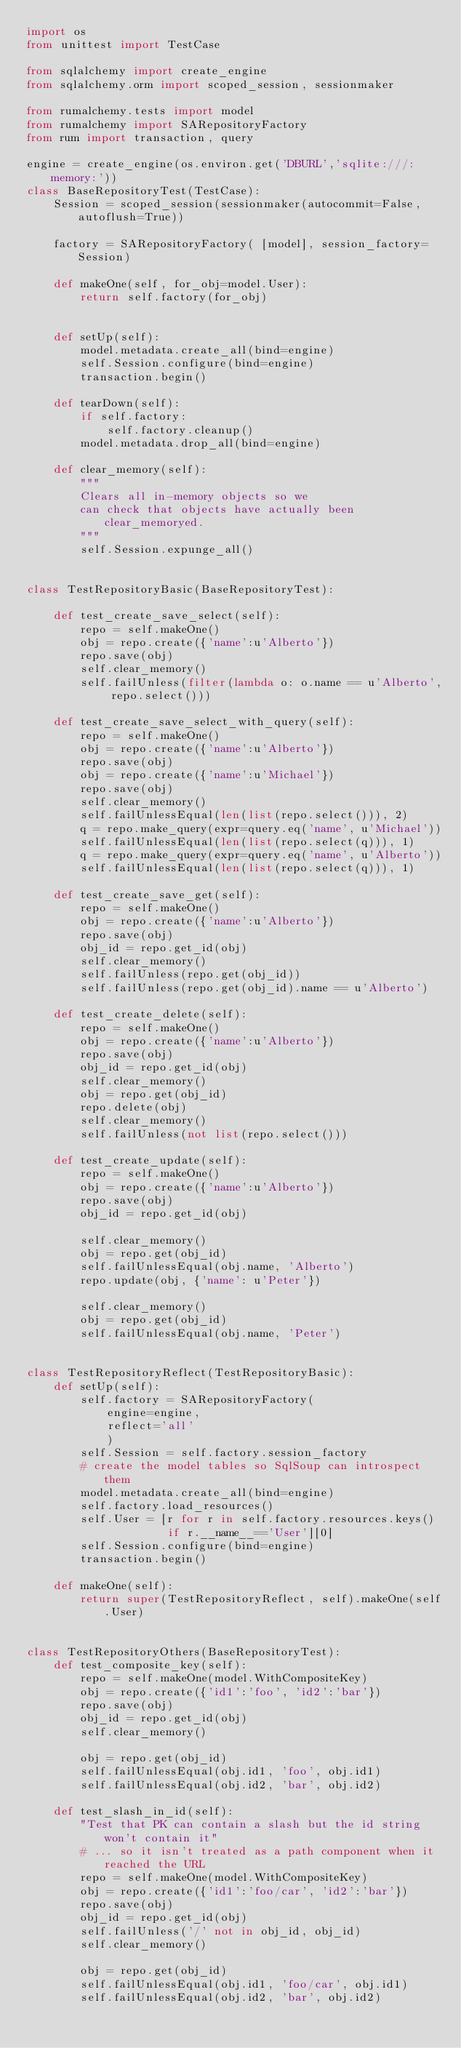<code> <loc_0><loc_0><loc_500><loc_500><_Python_>import os
from unittest import TestCase

from sqlalchemy import create_engine
from sqlalchemy.orm import scoped_session, sessionmaker

from rumalchemy.tests import model
from rumalchemy import SARepositoryFactory
from rum import transaction, query

engine = create_engine(os.environ.get('DBURL','sqlite:///:memory:'))
class BaseRepositoryTest(TestCase):
    Session = scoped_session(sessionmaker(autocommit=False, autoflush=True))

    factory = SARepositoryFactory( [model], session_factory=Session)

    def makeOne(self, for_obj=model.User):
        return self.factory(for_obj)


    def setUp(self):
        model.metadata.create_all(bind=engine)
        self.Session.configure(bind=engine)
        transaction.begin()

    def tearDown(self):
        if self.factory:
            self.factory.cleanup()
        model.metadata.drop_all(bind=engine)

    def clear_memory(self):
        """
        Clears all in-memory objects so we
        can check that objects have actually been clear_memoryed.
        """
        self.Session.expunge_all()


class TestRepositoryBasic(BaseRepositoryTest):

    def test_create_save_select(self):
        repo = self.makeOne()
        obj = repo.create({'name':u'Alberto'})
        repo.save(obj)
        self.clear_memory()
        self.failUnless(filter(lambda o: o.name == u'Alberto', repo.select()))

    def test_create_save_select_with_query(self):
        repo = self.makeOne()
        obj = repo.create({'name':u'Alberto'})
        repo.save(obj)
        obj = repo.create({'name':u'Michael'})
        repo.save(obj)
        self.clear_memory()
        self.failUnlessEqual(len(list(repo.select())), 2)
        q = repo.make_query(expr=query.eq('name', u'Michael'))
        self.failUnlessEqual(len(list(repo.select(q))), 1)
        q = repo.make_query(expr=query.eq('name', u'Alberto'))
        self.failUnlessEqual(len(list(repo.select(q))), 1)
    
    def test_create_save_get(self):
        repo = self.makeOne()
        obj = repo.create({'name':u'Alberto'})
        repo.save(obj)
        obj_id = repo.get_id(obj)
        self.clear_memory()
        self.failUnless(repo.get(obj_id))
        self.failUnless(repo.get(obj_id).name == u'Alberto')

    def test_create_delete(self):
        repo = self.makeOne()
        obj = repo.create({'name':u'Alberto'})
        repo.save(obj)
        obj_id = repo.get_id(obj)
        self.clear_memory()
        obj = repo.get(obj_id)
        repo.delete(obj)
        self.clear_memory()
        self.failUnless(not list(repo.select()))

    def test_create_update(self):
        repo = self.makeOne()
        obj = repo.create({'name':u'Alberto'})
        repo.save(obj)
        obj_id = repo.get_id(obj)

        self.clear_memory()
        obj = repo.get(obj_id)
        self.failUnlessEqual(obj.name, 'Alberto')
        repo.update(obj, {'name': u'Peter'})

        self.clear_memory()
        obj = repo.get(obj_id)
        self.failUnlessEqual(obj.name, 'Peter')

        
class TestRepositoryReflect(TestRepositoryBasic):
    def setUp(self):
        self.factory = SARepositoryFactory(
            engine=engine,
            reflect='all'
            )
        self.Session = self.factory.session_factory
        # create the model tables so SqlSoup can introspect them
        model.metadata.create_all(bind=engine)
        self.factory.load_resources()
        self.User = [r for r in self.factory.resources.keys()
                     if r.__name__=='User'][0]
        self.Session.configure(bind=engine)
        transaction.begin()

    def makeOne(self):
        return super(TestRepositoryReflect, self).makeOne(self.User)


class TestRepositoryOthers(BaseRepositoryTest):
    def test_composite_key(self):
        repo = self.makeOne(model.WithCompositeKey)
        obj = repo.create({'id1':'foo', 'id2':'bar'})
        repo.save(obj)
        obj_id = repo.get_id(obj)
        self.clear_memory()

        obj = repo.get(obj_id)
        self.failUnlessEqual(obj.id1, 'foo', obj.id1)
        self.failUnlessEqual(obj.id2, 'bar', obj.id2)

    def test_slash_in_id(self):
        "Test that PK can contain a slash but the id string won't contain it"
        # ... so it isn't treated as a path component when it reached the URL
        repo = self.makeOne(model.WithCompositeKey)
        obj = repo.create({'id1':'foo/car', 'id2':'bar'})
        repo.save(obj)
        obj_id = repo.get_id(obj)
        self.failUnless('/' not in obj_id, obj_id)
        self.clear_memory()

        obj = repo.get(obj_id)
        self.failUnlessEqual(obj.id1, 'foo/car', obj.id1)
        self.failUnlessEqual(obj.id2, 'bar', obj.id2)
</code> 